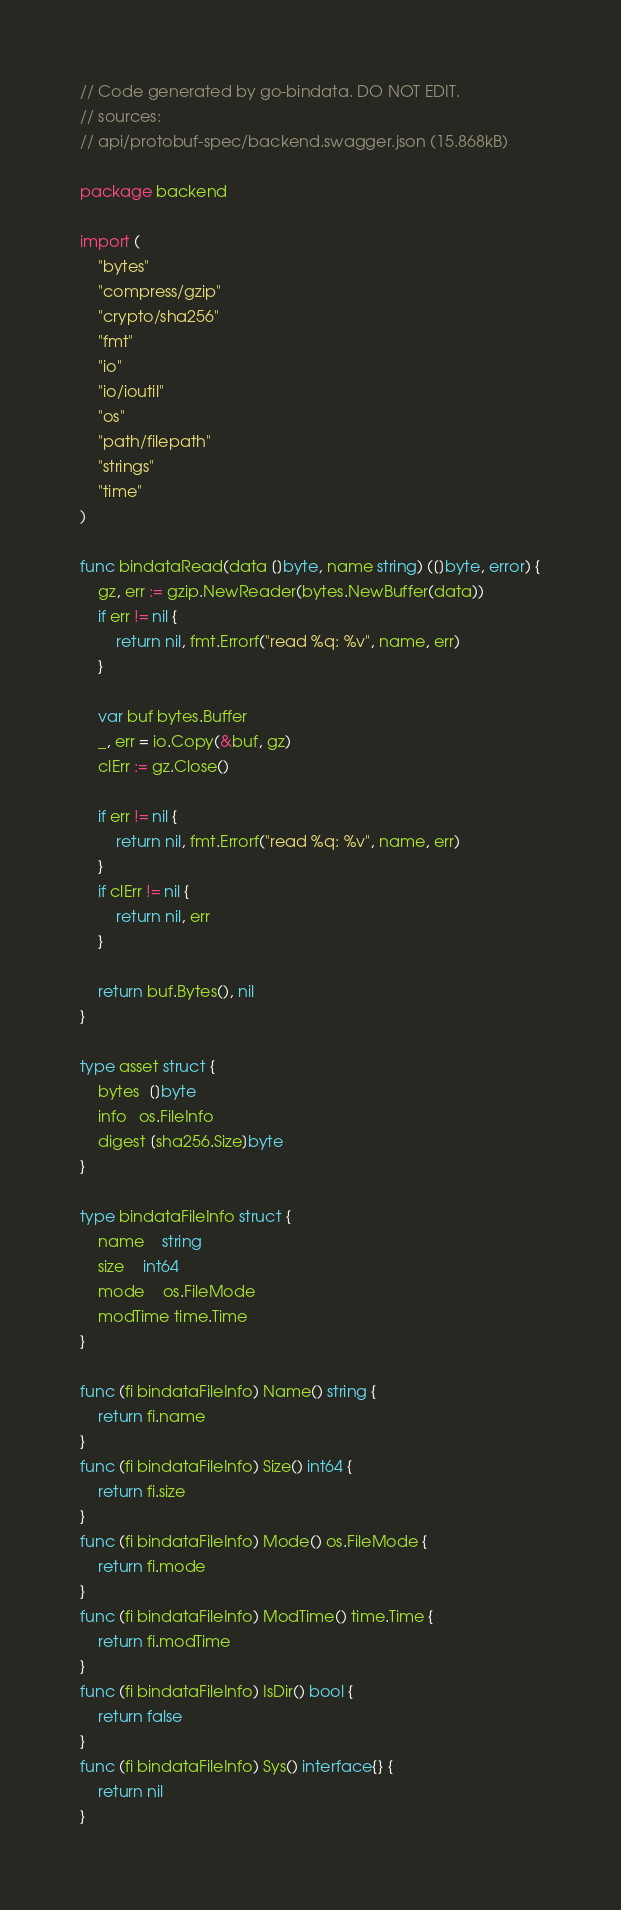<code> <loc_0><loc_0><loc_500><loc_500><_Go_>// Code generated by go-bindata. DO NOT EDIT.
// sources:
// api/protobuf-spec/backend.swagger.json (15.868kB)

package backend

import (
	"bytes"
	"compress/gzip"
	"crypto/sha256"
	"fmt"
	"io"
	"io/ioutil"
	"os"
	"path/filepath"
	"strings"
	"time"
)

func bindataRead(data []byte, name string) ([]byte, error) {
	gz, err := gzip.NewReader(bytes.NewBuffer(data))
	if err != nil {
		return nil, fmt.Errorf("read %q: %v", name, err)
	}

	var buf bytes.Buffer
	_, err = io.Copy(&buf, gz)
	clErr := gz.Close()

	if err != nil {
		return nil, fmt.Errorf("read %q: %v", name, err)
	}
	if clErr != nil {
		return nil, err
	}

	return buf.Bytes(), nil
}

type asset struct {
	bytes  []byte
	info   os.FileInfo
	digest [sha256.Size]byte
}

type bindataFileInfo struct {
	name    string
	size    int64
	mode    os.FileMode
	modTime time.Time
}

func (fi bindataFileInfo) Name() string {
	return fi.name
}
func (fi bindataFileInfo) Size() int64 {
	return fi.size
}
func (fi bindataFileInfo) Mode() os.FileMode {
	return fi.mode
}
func (fi bindataFileInfo) ModTime() time.Time {
	return fi.modTime
}
func (fi bindataFileInfo) IsDir() bool {
	return false
}
func (fi bindataFileInfo) Sys() interface{} {
	return nil
}
</code> 